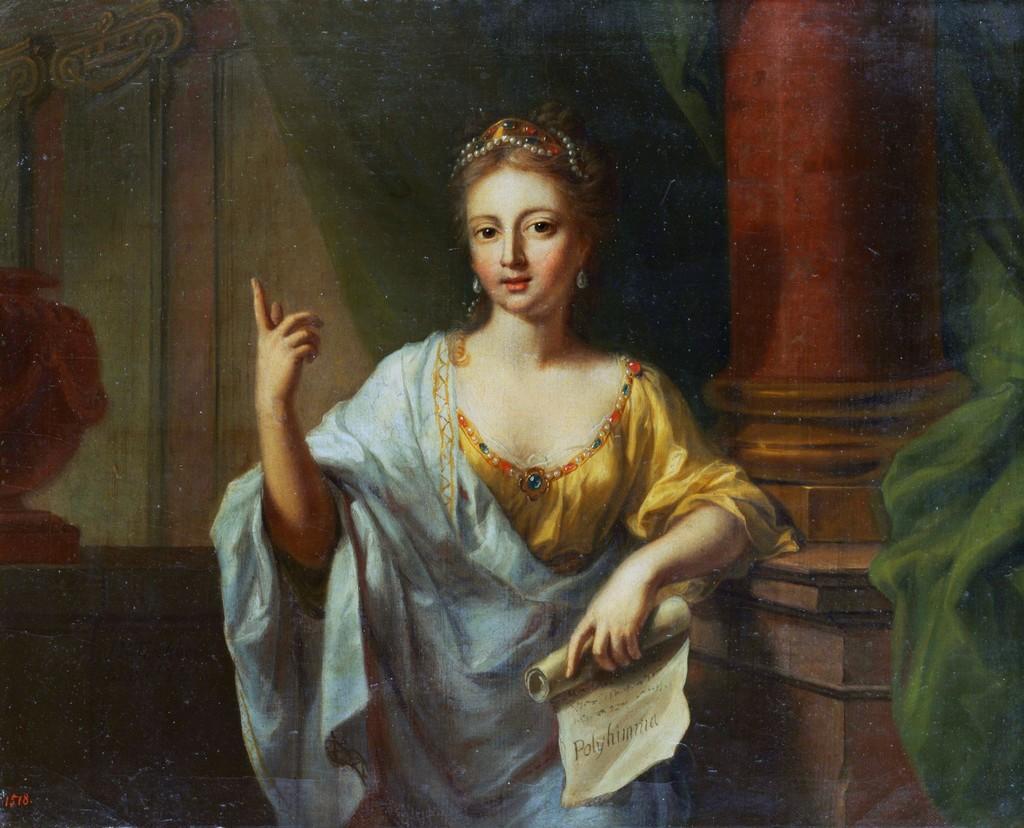Describe this image in one or two sentences. This is a picture of a painting, where there is a person standing and holding a paper , and in the background there is a pot and pillar. 